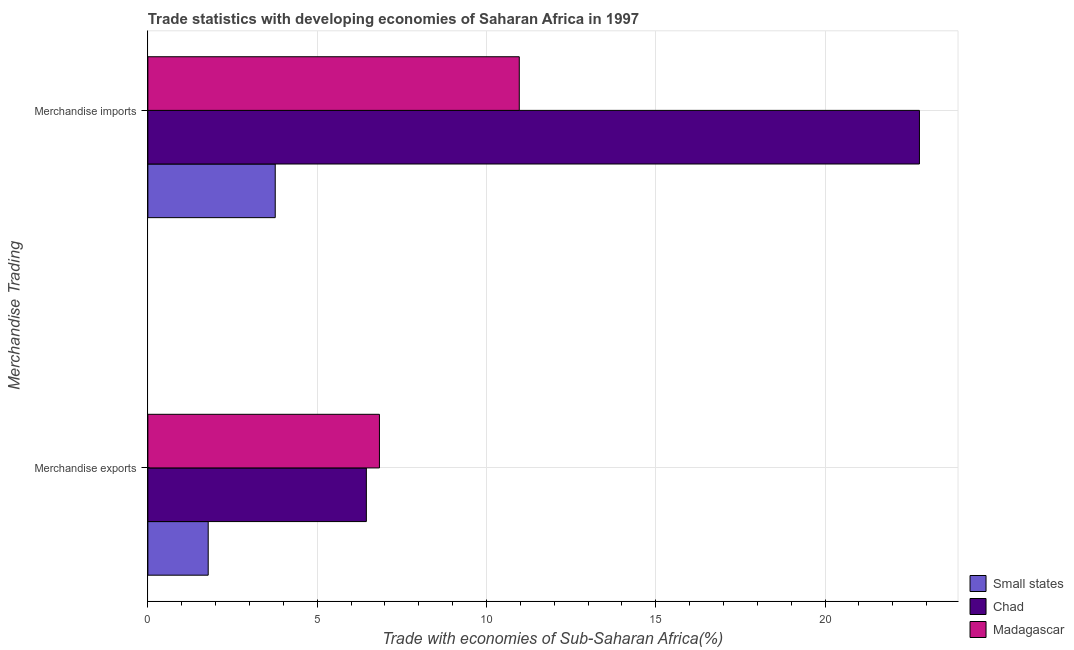How many different coloured bars are there?
Make the answer very short. 3. How many groups of bars are there?
Ensure brevity in your answer.  2. How many bars are there on the 1st tick from the bottom?
Keep it short and to the point. 3. What is the merchandise imports in Chad?
Give a very brief answer. 22.79. Across all countries, what is the maximum merchandise exports?
Give a very brief answer. 6.84. Across all countries, what is the minimum merchandise imports?
Provide a short and direct response. 3.76. In which country was the merchandise imports maximum?
Ensure brevity in your answer.  Chad. In which country was the merchandise exports minimum?
Your answer should be very brief. Small states. What is the total merchandise exports in the graph?
Offer a terse response. 15.07. What is the difference between the merchandise imports in Small states and that in Madagascar?
Keep it short and to the point. -7.21. What is the difference between the merchandise imports in Small states and the merchandise exports in Madagascar?
Your answer should be compact. -3.08. What is the average merchandise imports per country?
Ensure brevity in your answer.  12.51. What is the difference between the merchandise imports and merchandise exports in Small states?
Offer a very short reply. 1.98. What is the ratio of the merchandise exports in Small states to that in Madagascar?
Your response must be concise. 0.26. In how many countries, is the merchandise exports greater than the average merchandise exports taken over all countries?
Your answer should be very brief. 2. What does the 2nd bar from the top in Merchandise imports represents?
Offer a very short reply. Chad. What does the 3rd bar from the bottom in Merchandise exports represents?
Give a very brief answer. Madagascar. Are all the bars in the graph horizontal?
Offer a very short reply. Yes. Are the values on the major ticks of X-axis written in scientific E-notation?
Provide a succinct answer. No. How many legend labels are there?
Ensure brevity in your answer.  3. How are the legend labels stacked?
Provide a short and direct response. Vertical. What is the title of the graph?
Provide a succinct answer. Trade statistics with developing economies of Saharan Africa in 1997. What is the label or title of the X-axis?
Make the answer very short. Trade with economies of Sub-Saharan Africa(%). What is the label or title of the Y-axis?
Keep it short and to the point. Merchandise Trading. What is the Trade with economies of Sub-Saharan Africa(%) in Small states in Merchandise exports?
Provide a short and direct response. 1.78. What is the Trade with economies of Sub-Saharan Africa(%) in Chad in Merchandise exports?
Ensure brevity in your answer.  6.45. What is the Trade with economies of Sub-Saharan Africa(%) of Madagascar in Merchandise exports?
Offer a terse response. 6.84. What is the Trade with economies of Sub-Saharan Africa(%) of Small states in Merchandise imports?
Offer a very short reply. 3.76. What is the Trade with economies of Sub-Saharan Africa(%) of Chad in Merchandise imports?
Provide a succinct answer. 22.79. What is the Trade with economies of Sub-Saharan Africa(%) in Madagascar in Merchandise imports?
Your answer should be compact. 10.97. Across all Merchandise Trading, what is the maximum Trade with economies of Sub-Saharan Africa(%) in Small states?
Ensure brevity in your answer.  3.76. Across all Merchandise Trading, what is the maximum Trade with economies of Sub-Saharan Africa(%) in Chad?
Ensure brevity in your answer.  22.79. Across all Merchandise Trading, what is the maximum Trade with economies of Sub-Saharan Africa(%) of Madagascar?
Provide a succinct answer. 10.97. Across all Merchandise Trading, what is the minimum Trade with economies of Sub-Saharan Africa(%) in Small states?
Make the answer very short. 1.78. Across all Merchandise Trading, what is the minimum Trade with economies of Sub-Saharan Africa(%) of Chad?
Provide a succinct answer. 6.45. Across all Merchandise Trading, what is the minimum Trade with economies of Sub-Saharan Africa(%) of Madagascar?
Your response must be concise. 6.84. What is the total Trade with economies of Sub-Saharan Africa(%) of Small states in the graph?
Provide a succinct answer. 5.54. What is the total Trade with economies of Sub-Saharan Africa(%) of Chad in the graph?
Make the answer very short. 29.24. What is the total Trade with economies of Sub-Saharan Africa(%) in Madagascar in the graph?
Your answer should be compact. 17.81. What is the difference between the Trade with economies of Sub-Saharan Africa(%) in Small states in Merchandise exports and that in Merchandise imports?
Your answer should be very brief. -1.98. What is the difference between the Trade with economies of Sub-Saharan Africa(%) in Chad in Merchandise exports and that in Merchandise imports?
Make the answer very short. -16.34. What is the difference between the Trade with economies of Sub-Saharan Africa(%) in Madagascar in Merchandise exports and that in Merchandise imports?
Your response must be concise. -4.13. What is the difference between the Trade with economies of Sub-Saharan Africa(%) in Small states in Merchandise exports and the Trade with economies of Sub-Saharan Africa(%) in Chad in Merchandise imports?
Provide a succinct answer. -21.01. What is the difference between the Trade with economies of Sub-Saharan Africa(%) of Small states in Merchandise exports and the Trade with economies of Sub-Saharan Africa(%) of Madagascar in Merchandise imports?
Ensure brevity in your answer.  -9.19. What is the difference between the Trade with economies of Sub-Saharan Africa(%) of Chad in Merchandise exports and the Trade with economies of Sub-Saharan Africa(%) of Madagascar in Merchandise imports?
Make the answer very short. -4.52. What is the average Trade with economies of Sub-Saharan Africa(%) of Small states per Merchandise Trading?
Your response must be concise. 2.77. What is the average Trade with economies of Sub-Saharan Africa(%) of Chad per Merchandise Trading?
Offer a terse response. 14.62. What is the average Trade with economies of Sub-Saharan Africa(%) of Madagascar per Merchandise Trading?
Make the answer very short. 8.9. What is the difference between the Trade with economies of Sub-Saharan Africa(%) of Small states and Trade with economies of Sub-Saharan Africa(%) of Chad in Merchandise exports?
Give a very brief answer. -4.67. What is the difference between the Trade with economies of Sub-Saharan Africa(%) of Small states and Trade with economies of Sub-Saharan Africa(%) of Madagascar in Merchandise exports?
Provide a short and direct response. -5.06. What is the difference between the Trade with economies of Sub-Saharan Africa(%) of Chad and Trade with economies of Sub-Saharan Africa(%) of Madagascar in Merchandise exports?
Provide a short and direct response. -0.39. What is the difference between the Trade with economies of Sub-Saharan Africa(%) in Small states and Trade with economies of Sub-Saharan Africa(%) in Chad in Merchandise imports?
Your answer should be compact. -19.03. What is the difference between the Trade with economies of Sub-Saharan Africa(%) of Small states and Trade with economies of Sub-Saharan Africa(%) of Madagascar in Merchandise imports?
Provide a succinct answer. -7.21. What is the difference between the Trade with economies of Sub-Saharan Africa(%) of Chad and Trade with economies of Sub-Saharan Africa(%) of Madagascar in Merchandise imports?
Offer a very short reply. 11.82. What is the ratio of the Trade with economies of Sub-Saharan Africa(%) in Small states in Merchandise exports to that in Merchandise imports?
Keep it short and to the point. 0.47. What is the ratio of the Trade with economies of Sub-Saharan Africa(%) of Chad in Merchandise exports to that in Merchandise imports?
Provide a short and direct response. 0.28. What is the ratio of the Trade with economies of Sub-Saharan Africa(%) in Madagascar in Merchandise exports to that in Merchandise imports?
Offer a terse response. 0.62. What is the difference between the highest and the second highest Trade with economies of Sub-Saharan Africa(%) in Small states?
Give a very brief answer. 1.98. What is the difference between the highest and the second highest Trade with economies of Sub-Saharan Africa(%) in Chad?
Offer a very short reply. 16.34. What is the difference between the highest and the second highest Trade with economies of Sub-Saharan Africa(%) of Madagascar?
Give a very brief answer. 4.13. What is the difference between the highest and the lowest Trade with economies of Sub-Saharan Africa(%) in Small states?
Ensure brevity in your answer.  1.98. What is the difference between the highest and the lowest Trade with economies of Sub-Saharan Africa(%) of Chad?
Offer a very short reply. 16.34. What is the difference between the highest and the lowest Trade with economies of Sub-Saharan Africa(%) in Madagascar?
Your answer should be compact. 4.13. 